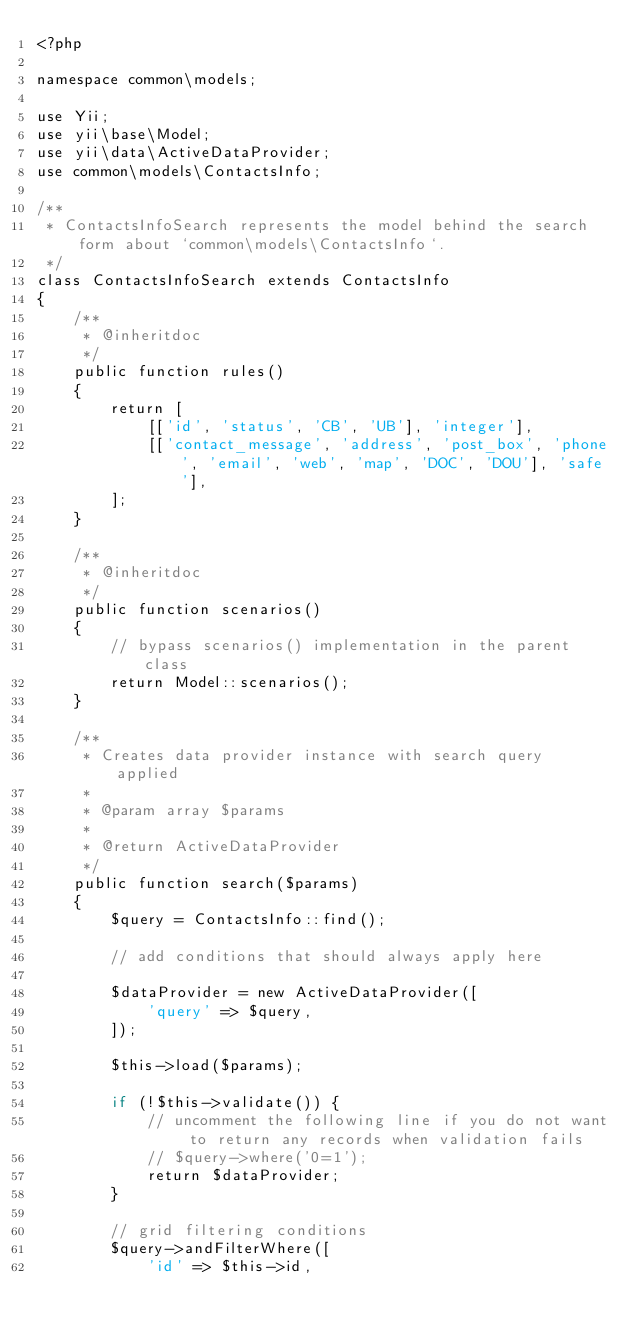Convert code to text. <code><loc_0><loc_0><loc_500><loc_500><_PHP_><?php

namespace common\models;

use Yii;
use yii\base\Model;
use yii\data\ActiveDataProvider;
use common\models\ContactsInfo;

/**
 * ContactsInfoSearch represents the model behind the search form about `common\models\ContactsInfo`.
 */
class ContactsInfoSearch extends ContactsInfo
{
    /**
     * @inheritdoc
     */
    public function rules()
    {
        return [
            [['id', 'status', 'CB', 'UB'], 'integer'],
            [['contact_message', 'address', 'post_box', 'phone', 'email', 'web', 'map', 'DOC', 'DOU'], 'safe'],
        ];
    }

    /**
     * @inheritdoc
     */
    public function scenarios()
    {
        // bypass scenarios() implementation in the parent class
        return Model::scenarios();
    }

    /**
     * Creates data provider instance with search query applied
     *
     * @param array $params
     *
     * @return ActiveDataProvider
     */
    public function search($params)
    {
        $query = ContactsInfo::find();

        // add conditions that should always apply here

        $dataProvider = new ActiveDataProvider([
            'query' => $query,
        ]);

        $this->load($params);

        if (!$this->validate()) {
            // uncomment the following line if you do not want to return any records when validation fails
            // $query->where('0=1');
            return $dataProvider;
        }

        // grid filtering conditions
        $query->andFilterWhere([
            'id' => $this->id,</code> 